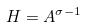Convert formula to latex. <formula><loc_0><loc_0><loc_500><loc_500>H = A ^ { \sigma - 1 }</formula> 